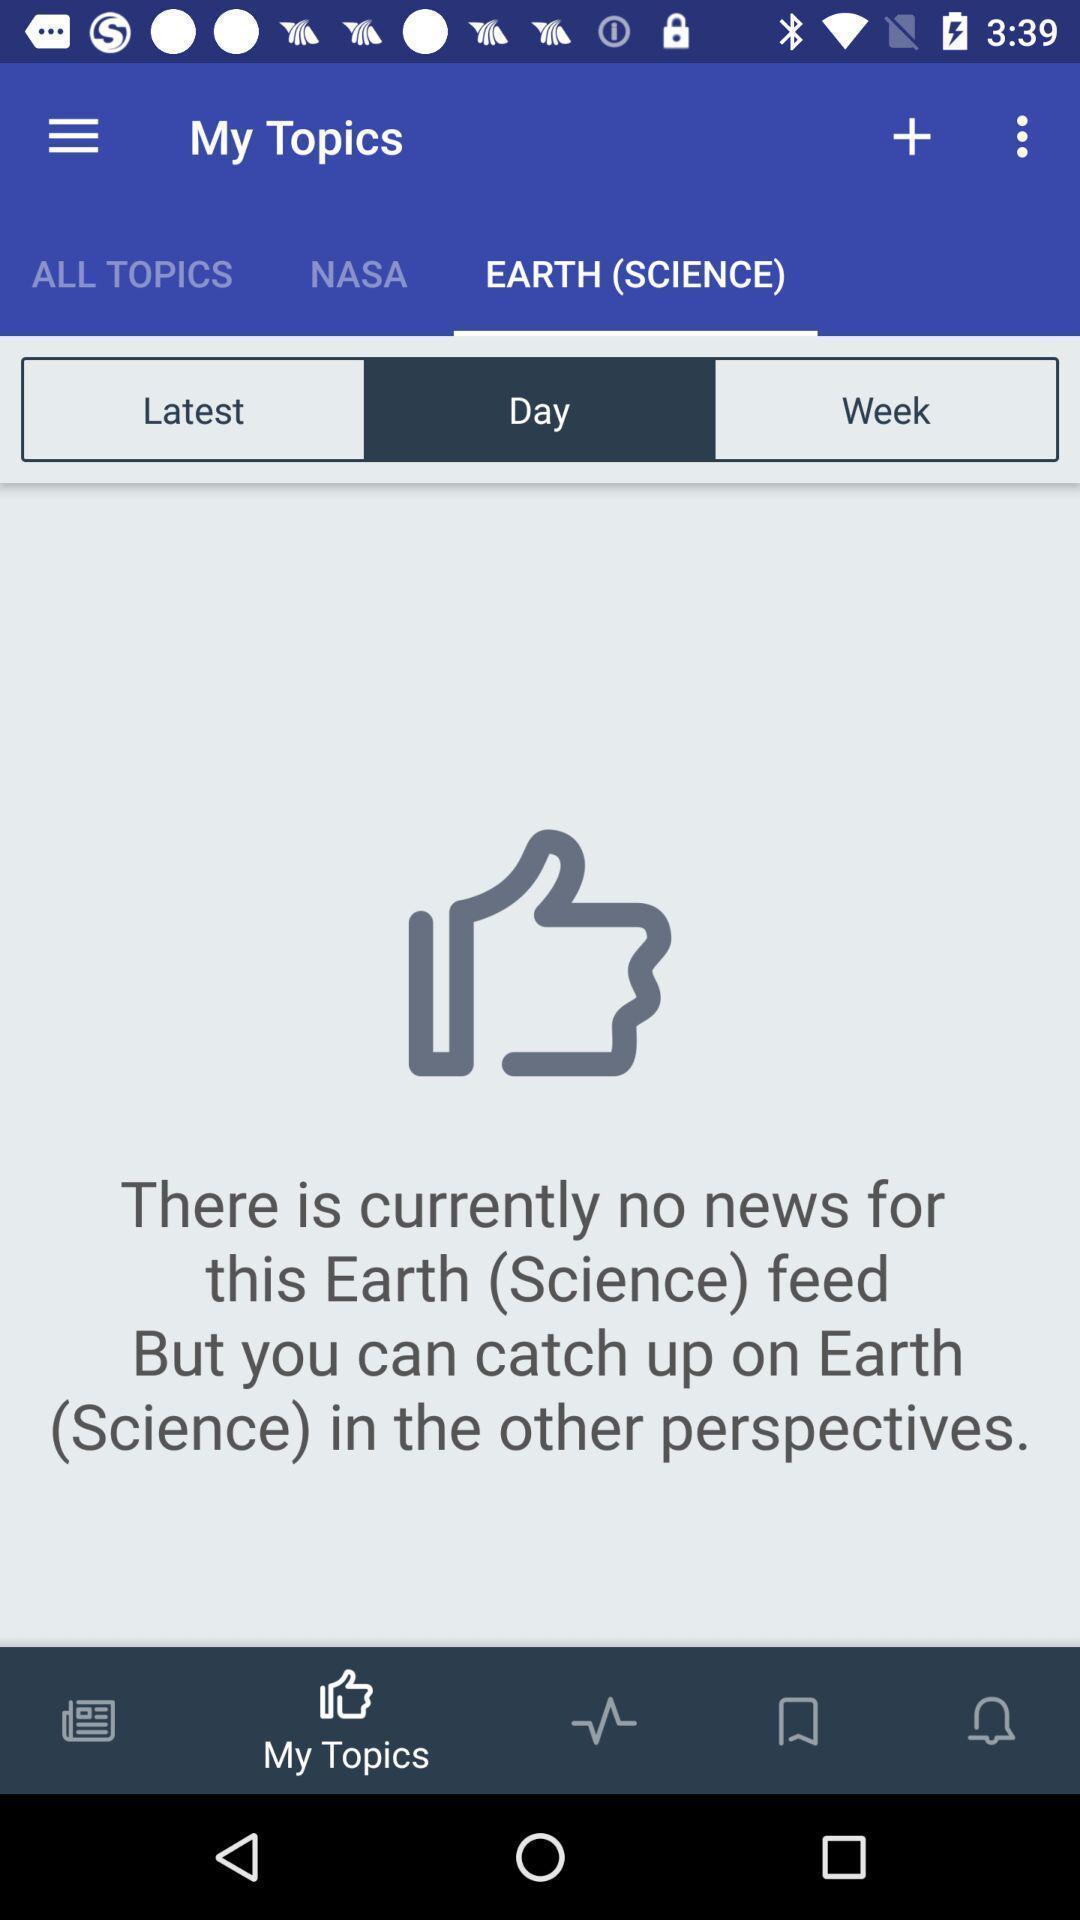Describe this image in words. Page displaying topics page of a learning app. 